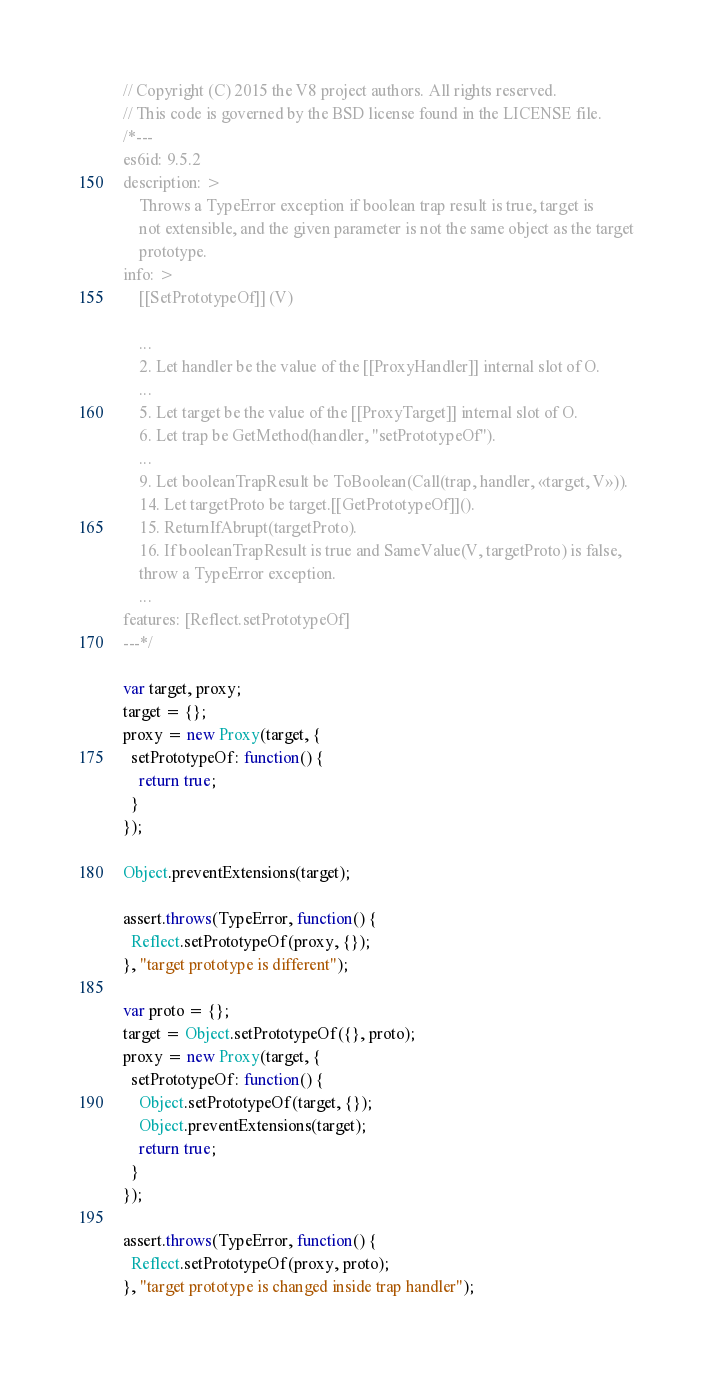<code> <loc_0><loc_0><loc_500><loc_500><_JavaScript_>// Copyright (C) 2015 the V8 project authors. All rights reserved.
// This code is governed by the BSD license found in the LICENSE file.
/*---
es6id: 9.5.2
description: >
    Throws a TypeError exception if boolean trap result is true, target is
    not extensible, and the given parameter is not the same object as the target
    prototype.
info: >
    [[SetPrototypeOf]] (V)

    ...
    2. Let handler be the value of the [[ProxyHandler]] internal slot of O.
    ...
    5. Let target be the value of the [[ProxyTarget]] internal slot of O.
    6. Let trap be GetMethod(handler, "setPrototypeOf").
    ...
    9. Let booleanTrapResult be ToBoolean(Call(trap, handler, «target, V»)).
    14. Let targetProto be target.[[GetPrototypeOf]]().
    15. ReturnIfAbrupt(targetProto).
    16. If booleanTrapResult is true and SameValue(V, targetProto) is false,
    throw a TypeError exception.
    ...
features: [Reflect.setPrototypeOf]
---*/

var target, proxy;
target = {};
proxy = new Proxy(target, {
  setPrototypeOf: function() {
    return true;
  }
});

Object.preventExtensions(target);

assert.throws(TypeError, function() {
  Reflect.setPrototypeOf(proxy, {});
}, "target prototype is different");

var proto = {};
target = Object.setPrototypeOf({}, proto);
proxy = new Proxy(target, {
  setPrototypeOf: function() {
    Object.setPrototypeOf(target, {});
    Object.preventExtensions(target);
    return true;
  }
});

assert.throws(TypeError, function() {
  Reflect.setPrototypeOf(proxy, proto);
}, "target prototype is changed inside trap handler");
</code> 